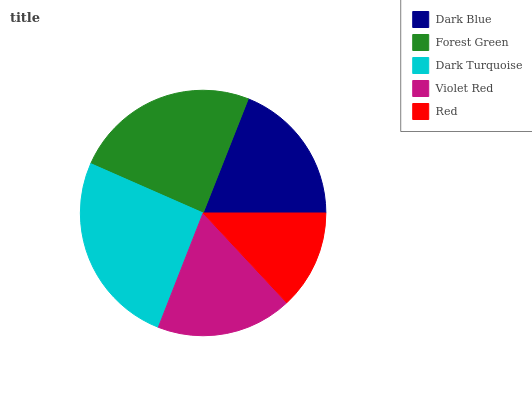Is Red the minimum?
Answer yes or no. Yes. Is Dark Turquoise the maximum?
Answer yes or no. Yes. Is Forest Green the minimum?
Answer yes or no. No. Is Forest Green the maximum?
Answer yes or no. No. Is Forest Green greater than Dark Blue?
Answer yes or no. Yes. Is Dark Blue less than Forest Green?
Answer yes or no. Yes. Is Dark Blue greater than Forest Green?
Answer yes or no. No. Is Forest Green less than Dark Blue?
Answer yes or no. No. Is Dark Blue the high median?
Answer yes or no. Yes. Is Dark Blue the low median?
Answer yes or no. Yes. Is Dark Turquoise the high median?
Answer yes or no. No. Is Red the low median?
Answer yes or no. No. 